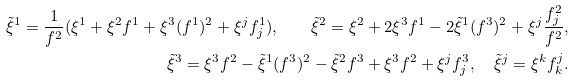<formula> <loc_0><loc_0><loc_500><loc_500>\tilde { \xi } ^ { 1 } = \frac { 1 } { f ^ { 2 } } ( \xi ^ { 1 } + \xi ^ { 2 } f ^ { 1 } + \xi ^ { 3 } ( f ^ { 1 } ) ^ { 2 } + \xi ^ { j } f ^ { 1 } _ { j } ) , \quad \tilde { \xi } ^ { 2 } = \xi ^ { 2 } + 2 \xi ^ { 3 } f ^ { 1 } - 2 \tilde { \xi } ^ { 1 } ( f ^ { 3 } ) ^ { 2 } + \xi ^ { j } \frac { f ^ { 2 } _ { j } } { f ^ { 2 } } , \\ \tilde { \xi } ^ { 3 } = \xi ^ { 3 } f ^ { 2 } - \tilde { \xi } ^ { 1 } ( f ^ { 3 } ) ^ { 2 } - \tilde { \xi } ^ { 2 } f ^ { 3 } + \xi ^ { 3 } f ^ { 2 } + \xi ^ { j } f ^ { 3 } _ { j } , \quad \tilde { \xi } ^ { j } = \xi ^ { k } f ^ { j } _ { k } .</formula> 